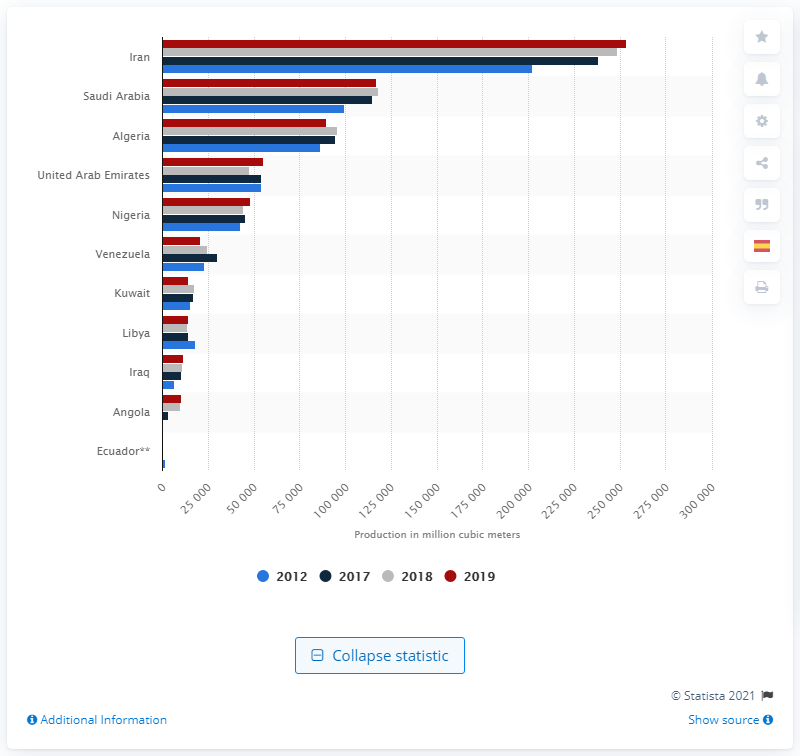List a handful of essential elements in this visual. Iran is the leading OPEC member in terms of natural gas production. 